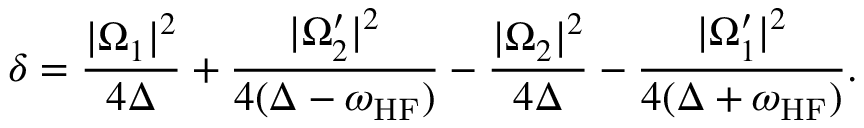<formula> <loc_0><loc_0><loc_500><loc_500>\delta = \frac { | \Omega _ { 1 } | ^ { 2 } } { 4 \Delta } + \frac { | \Omega _ { 2 } ^ { \prime } | ^ { 2 } } { 4 ( \Delta - \omega _ { H F } ) } - \frac { | \Omega _ { 2 } | ^ { 2 } } { 4 \Delta } - \frac { | \Omega _ { 1 } ^ { \prime } | ^ { 2 } } { 4 ( \Delta + \omega _ { H F } ) } .</formula> 